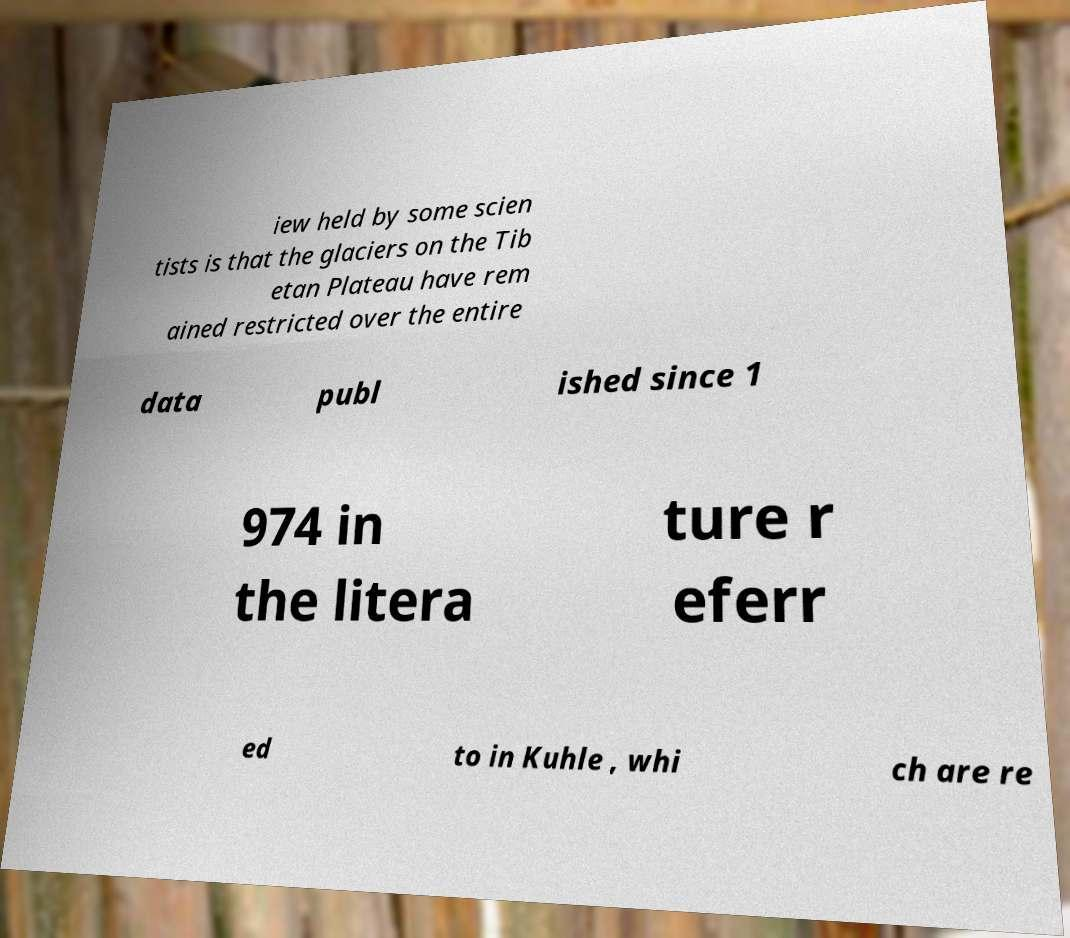There's text embedded in this image that I need extracted. Can you transcribe it verbatim? iew held by some scien tists is that the glaciers on the Tib etan Plateau have rem ained restricted over the entire data publ ished since 1 974 in the litera ture r eferr ed to in Kuhle , whi ch are re 